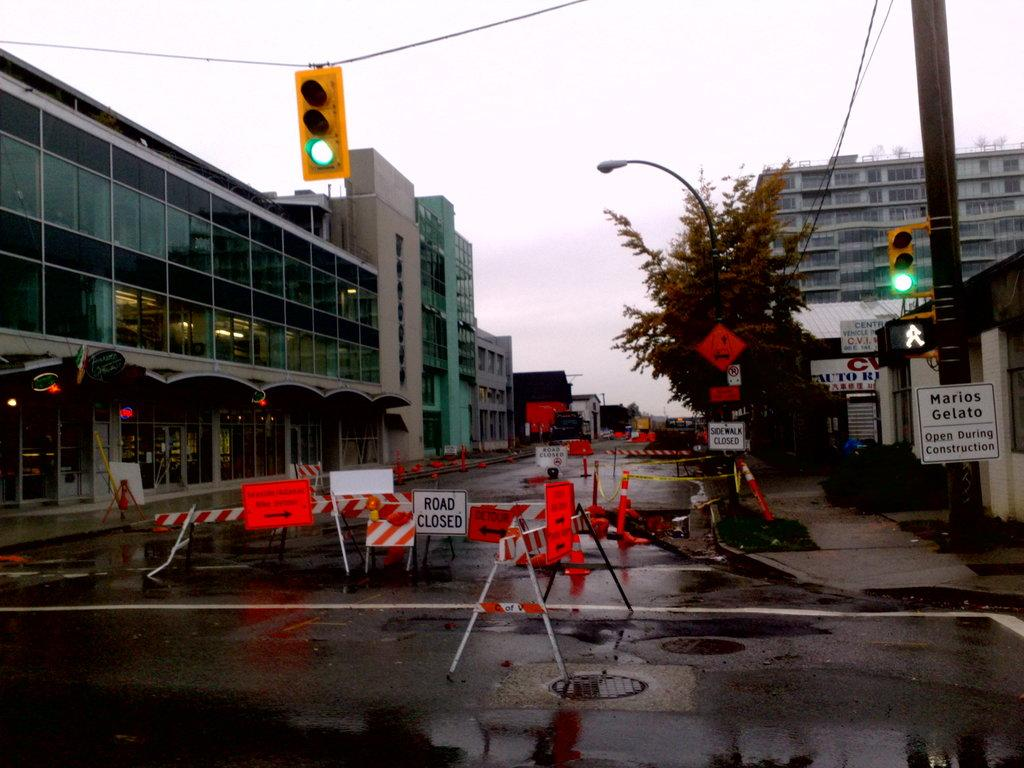What can be seen on both sides of the road in the image? There are buildings on both sides of the road. What is hanging from the rope in the image? There is a traffic light on a rope. What is present under the traffic light? There are caution ropes and other things under the traffic light. Can you tell me how much the oven costs in the image? There is no oven present in the image, so it is not possible to determine its cost. 